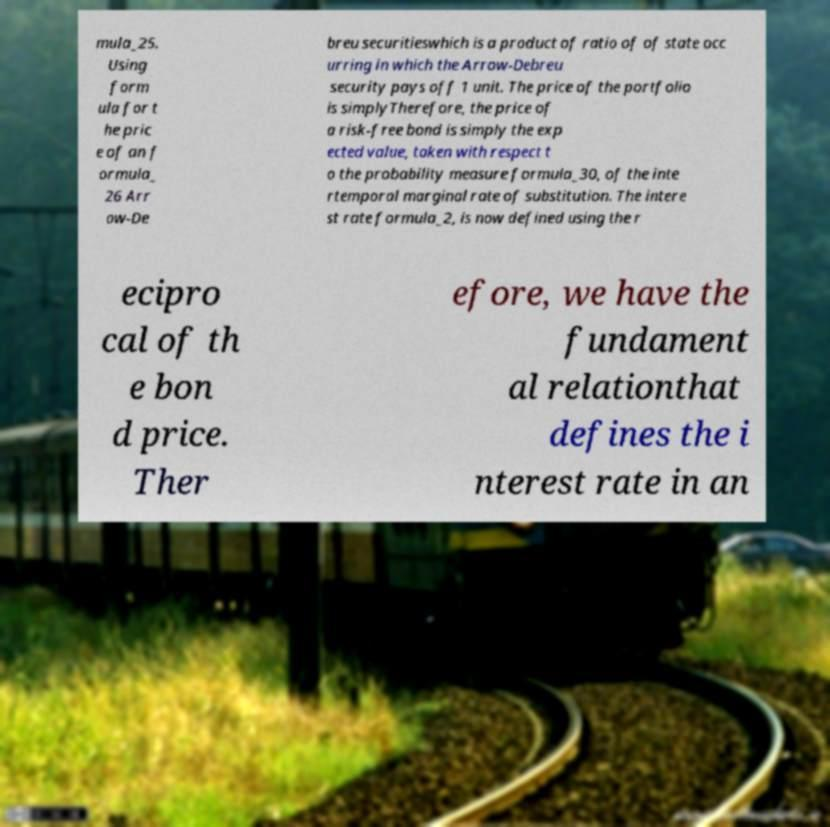Can you accurately transcribe the text from the provided image for me? mula_25. Using form ula for t he pric e of an f ormula_ 26 Arr ow-De breu securitieswhich is a product of ratio of of state occ urring in which the Arrow-Debreu security pays off 1 unit. The price of the portfolio is simplyTherefore, the price of a risk-free bond is simply the exp ected value, taken with respect t o the probability measure formula_30, of the inte rtemporal marginal rate of substitution. The intere st rate formula_2, is now defined using the r ecipro cal of th e bon d price. Ther efore, we have the fundament al relationthat defines the i nterest rate in an 